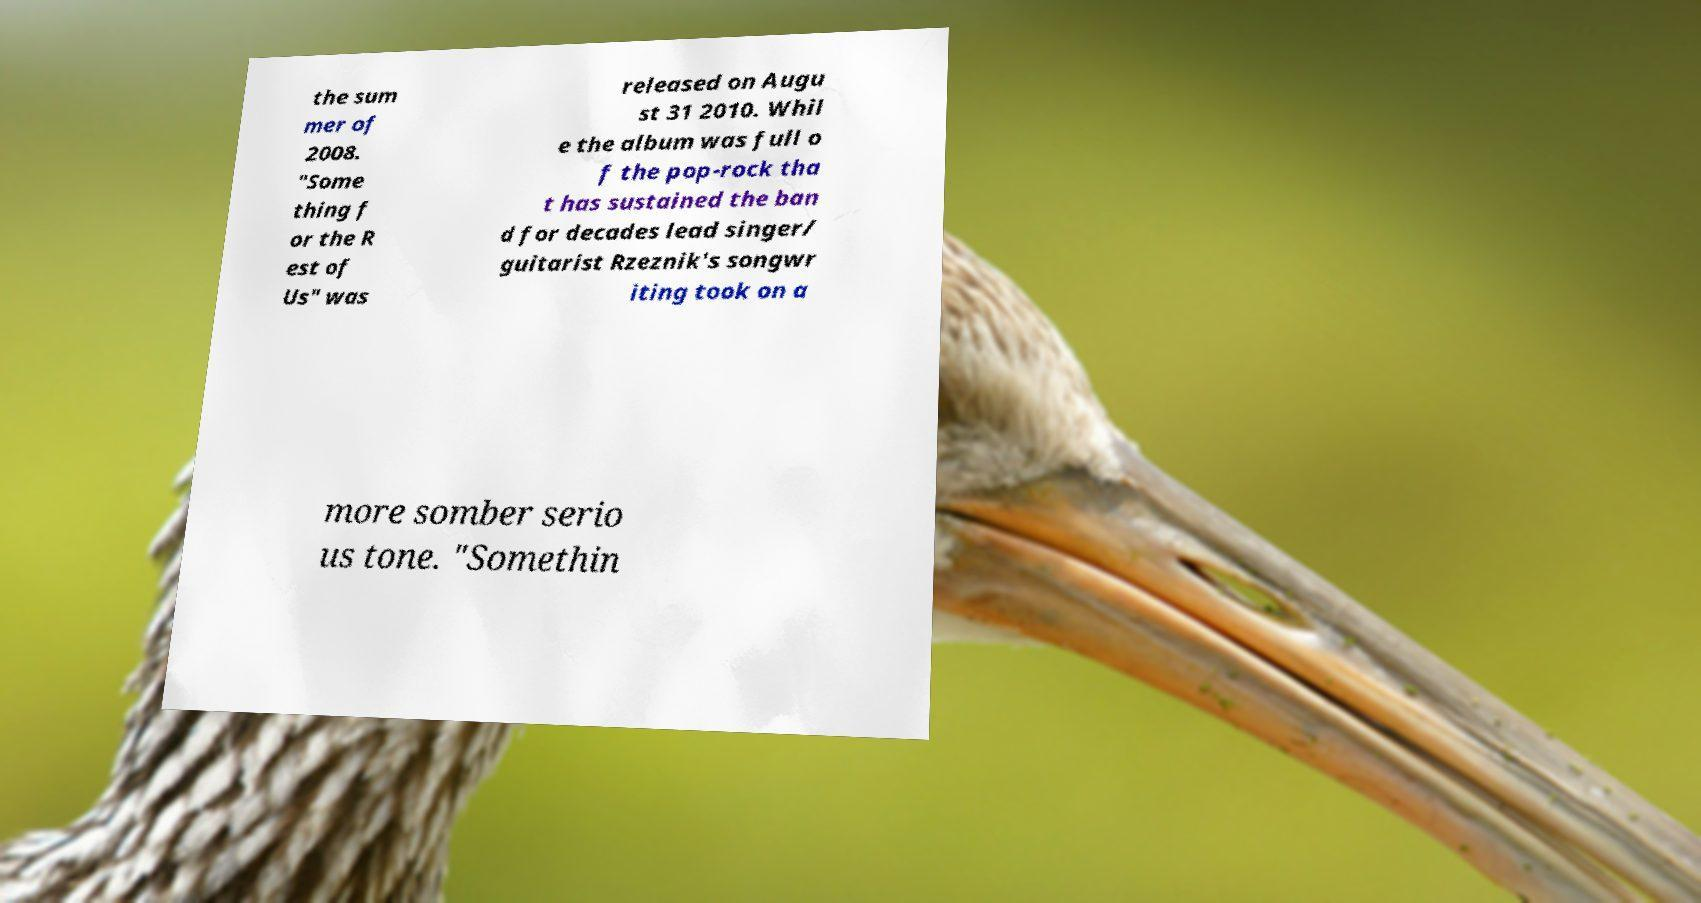Could you assist in decoding the text presented in this image and type it out clearly? the sum mer of 2008. "Some thing f or the R est of Us" was released on Augu st 31 2010. Whil e the album was full o f the pop-rock tha t has sustained the ban d for decades lead singer/ guitarist Rzeznik's songwr iting took on a more somber serio us tone. "Somethin 